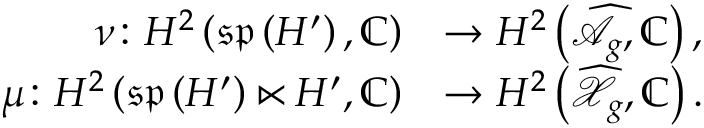<formula> <loc_0><loc_0><loc_500><loc_500>\begin{array} { r l } { \nu \colon H ^ { 2 } \left ( \mathfrak { s p } \left ( H ^ { \prime } \right ) , \mathbb { C } \right ) } & { \rightarrow H ^ { 2 } \left ( \widehat { \mathcal { A } } _ { g } , \mathbb { C } \right ) , } \\ { \mu \colon H ^ { 2 } \left ( \mathfrak { s p } \left ( H ^ { \prime } \right ) \ltimes H ^ { \prime } , \mathbb { C } \right ) } & { \rightarrow H ^ { 2 } \left ( \widehat { \mathcal { X } } _ { g } , \mathbb { C } \right ) . } \end{array}</formula> 